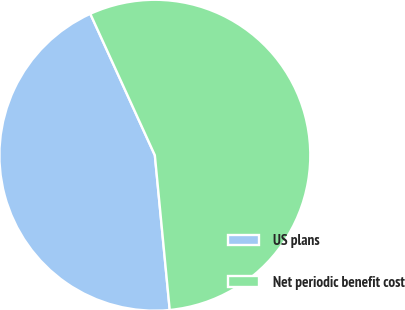Convert chart. <chart><loc_0><loc_0><loc_500><loc_500><pie_chart><fcel>US plans<fcel>Net periodic benefit cost<nl><fcel>44.71%<fcel>55.29%<nl></chart> 